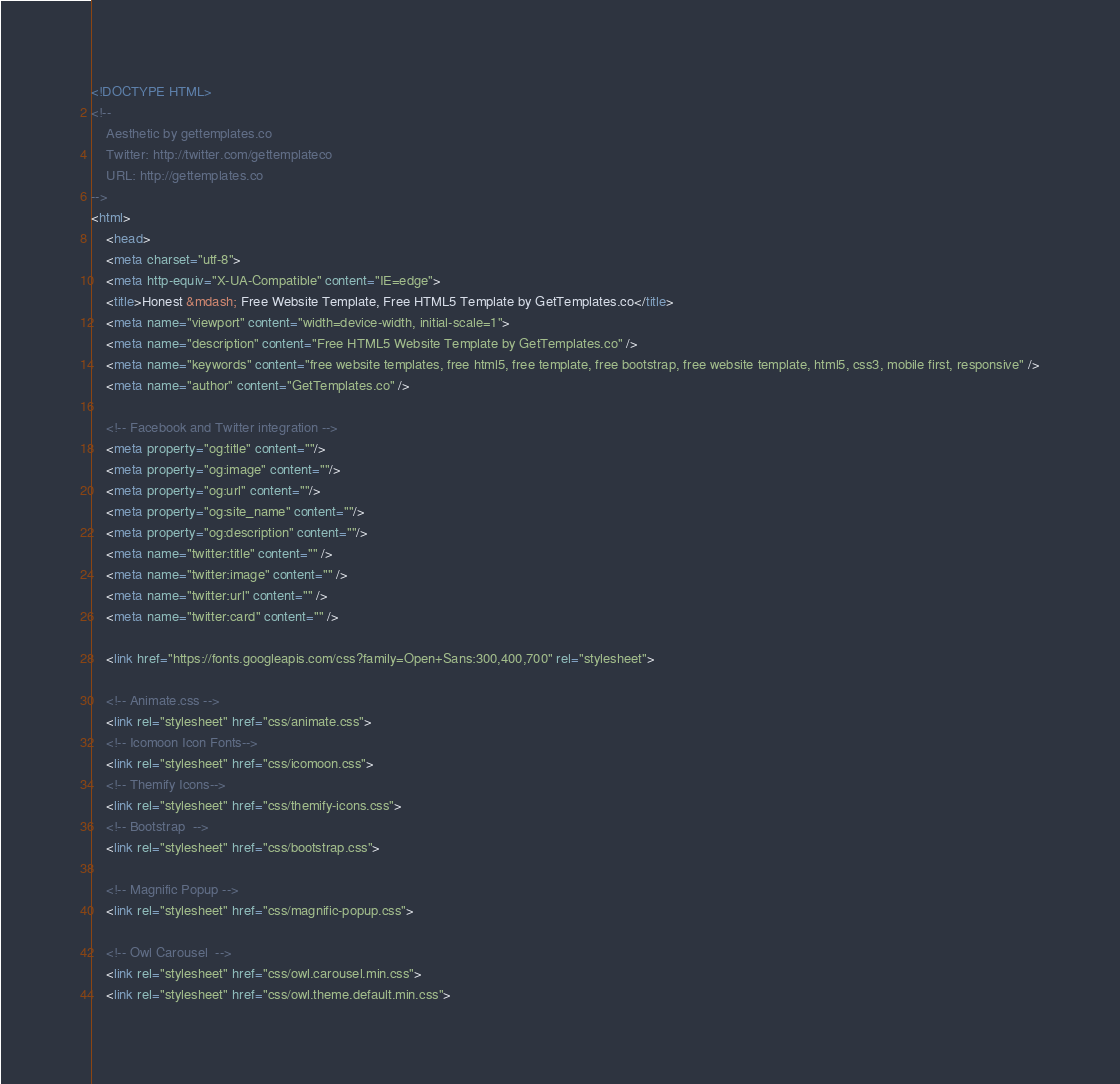<code> <loc_0><loc_0><loc_500><loc_500><_HTML_><!DOCTYPE HTML>
<!--
	Aesthetic by gettemplates.co
	Twitter: http://twitter.com/gettemplateco
	URL: http://gettemplates.co
-->
<html>
	<head>
	<meta charset="utf-8">
	<meta http-equiv="X-UA-Compatible" content="IE=edge">
	<title>Honest &mdash; Free Website Template, Free HTML5 Template by GetTemplates.co</title>
	<meta name="viewport" content="width=device-width, initial-scale=1">
	<meta name="description" content="Free HTML5 Website Template by GetTemplates.co" />
	<meta name="keywords" content="free website templates, free html5, free template, free bootstrap, free website template, html5, css3, mobile first, responsive" />
	<meta name="author" content="GetTemplates.co" />

  	<!-- Facebook and Twitter integration -->
	<meta property="og:title" content=""/>
	<meta property="og:image" content=""/>
	<meta property="og:url" content=""/>
	<meta property="og:site_name" content=""/>
	<meta property="og:description" content=""/>
	<meta name="twitter:title" content="" />
	<meta name="twitter:image" content="" />
	<meta name="twitter:url" content="" />
	<meta name="twitter:card" content="" />

	<link href="https://fonts.googleapis.com/css?family=Open+Sans:300,400,700" rel="stylesheet">
	
	<!-- Animate.css -->
	<link rel="stylesheet" href="css/animate.css">
	<!-- Icomoon Icon Fonts-->
	<link rel="stylesheet" href="css/icomoon.css">
	<!-- Themify Icons-->
	<link rel="stylesheet" href="css/themify-icons.css">
	<!-- Bootstrap  -->
	<link rel="stylesheet" href="css/bootstrap.css">

	<!-- Magnific Popup -->
	<link rel="stylesheet" href="css/magnific-popup.css">

	<!-- Owl Carousel  -->
	<link rel="stylesheet" href="css/owl.carousel.min.css">
	<link rel="stylesheet" href="css/owl.theme.default.min.css">
</code> 